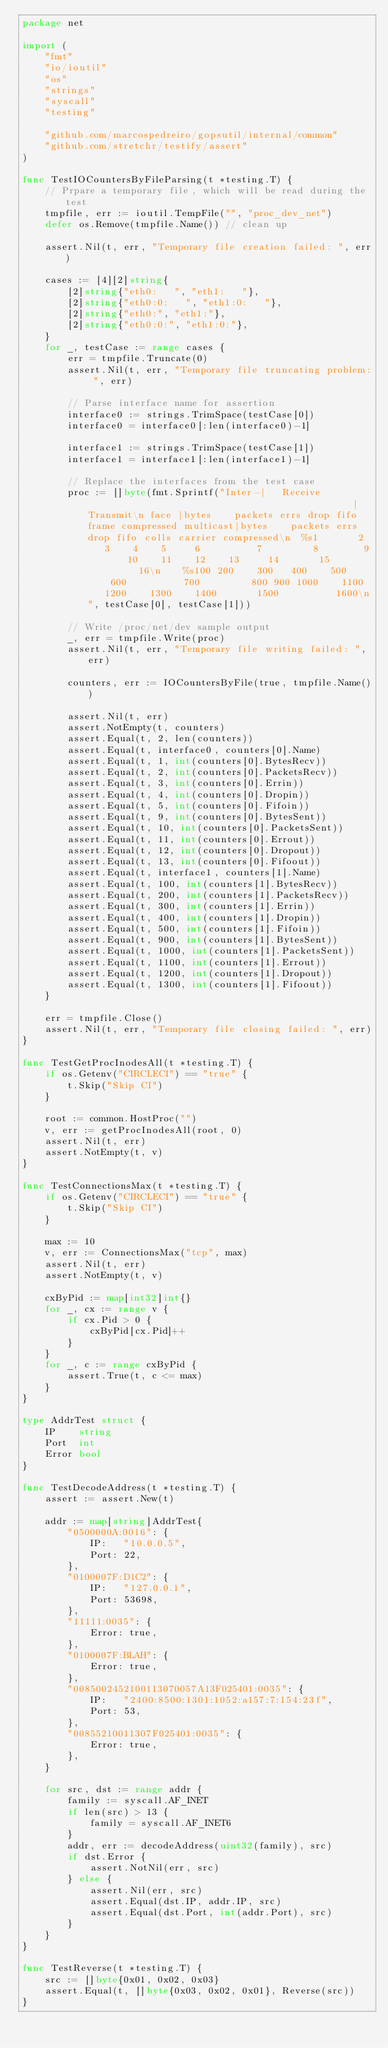Convert code to text. <code><loc_0><loc_0><loc_500><loc_500><_Go_>package net

import (
	"fmt"
	"io/ioutil"
	"os"
	"strings"
	"syscall"
	"testing"

	"github.com/marcospedreiro/gopsutil/internal/common"
	"github.com/stretchr/testify/assert"
)

func TestIOCountersByFileParsing(t *testing.T) {
	// Prpare a temporary file, which will be read during the test
	tmpfile, err := ioutil.TempFile("", "proc_dev_net")
	defer os.Remove(tmpfile.Name()) // clean up

	assert.Nil(t, err, "Temporary file creation failed: ", err)

	cases := [4][2]string{
		[2]string{"eth0:   ", "eth1:   "},
		[2]string{"eth0:0:   ", "eth1:0:   "},
		[2]string{"eth0:", "eth1:"},
		[2]string{"eth0:0:", "eth1:0:"},
	}
	for _, testCase := range cases {
		err = tmpfile.Truncate(0)
		assert.Nil(t, err, "Temporary file truncating problem: ", err)

		// Parse interface name for assertion
		interface0 := strings.TrimSpace(testCase[0])
		interface0 = interface0[:len(interface0)-1]

		interface1 := strings.TrimSpace(testCase[1])
		interface1 = interface1[:len(interface1)-1]

		// Replace the interfaces from the test case
		proc := []byte(fmt.Sprintf("Inter-|   Receive                                                |  Transmit\n face |bytes    packets errs drop fifo frame compressed multicast|bytes    packets errs drop fifo colls carrier compressed\n  %s1       2    3    4    5     6          7         8        9       10    11    12    13     14       15          16\n    %s100 200    300   400    500     600          700         800 900 1000    1100    1200    1300    1400       1500          1600\n", testCase[0], testCase[1]))

		// Write /proc/net/dev sample output
		_, err = tmpfile.Write(proc)
		assert.Nil(t, err, "Temporary file writing failed: ", err)

		counters, err := IOCountersByFile(true, tmpfile.Name())

		assert.Nil(t, err)
		assert.NotEmpty(t, counters)
		assert.Equal(t, 2, len(counters))
		assert.Equal(t, interface0, counters[0].Name)
		assert.Equal(t, 1, int(counters[0].BytesRecv))
		assert.Equal(t, 2, int(counters[0].PacketsRecv))
		assert.Equal(t, 3, int(counters[0].Errin))
		assert.Equal(t, 4, int(counters[0].Dropin))
		assert.Equal(t, 5, int(counters[0].Fifoin))
		assert.Equal(t, 9, int(counters[0].BytesSent))
		assert.Equal(t, 10, int(counters[0].PacketsSent))
		assert.Equal(t, 11, int(counters[0].Errout))
		assert.Equal(t, 12, int(counters[0].Dropout))
		assert.Equal(t, 13, int(counters[0].Fifoout))
		assert.Equal(t, interface1, counters[1].Name)
		assert.Equal(t, 100, int(counters[1].BytesRecv))
		assert.Equal(t, 200, int(counters[1].PacketsRecv))
		assert.Equal(t, 300, int(counters[1].Errin))
		assert.Equal(t, 400, int(counters[1].Dropin))
		assert.Equal(t, 500, int(counters[1].Fifoin))
		assert.Equal(t, 900, int(counters[1].BytesSent))
		assert.Equal(t, 1000, int(counters[1].PacketsSent))
		assert.Equal(t, 1100, int(counters[1].Errout))
		assert.Equal(t, 1200, int(counters[1].Dropout))
		assert.Equal(t, 1300, int(counters[1].Fifoout))
	}

	err = tmpfile.Close()
	assert.Nil(t, err, "Temporary file closing failed: ", err)
}

func TestGetProcInodesAll(t *testing.T) {
	if os.Getenv("CIRCLECI") == "true" {
		t.Skip("Skip CI")
	}

	root := common.HostProc("")
	v, err := getProcInodesAll(root, 0)
	assert.Nil(t, err)
	assert.NotEmpty(t, v)
}

func TestConnectionsMax(t *testing.T) {
	if os.Getenv("CIRCLECI") == "true" {
		t.Skip("Skip CI")
	}

	max := 10
	v, err := ConnectionsMax("tcp", max)
	assert.Nil(t, err)
	assert.NotEmpty(t, v)

	cxByPid := map[int32]int{}
	for _, cx := range v {
		if cx.Pid > 0 {
			cxByPid[cx.Pid]++
		}
	}
	for _, c := range cxByPid {
		assert.True(t, c <= max)
	}
}

type AddrTest struct {
	IP    string
	Port  int
	Error bool
}

func TestDecodeAddress(t *testing.T) {
	assert := assert.New(t)

	addr := map[string]AddrTest{
		"0500000A:0016": {
			IP:   "10.0.0.5",
			Port: 22,
		},
		"0100007F:D1C2": {
			IP:   "127.0.0.1",
			Port: 53698,
		},
		"11111:0035": {
			Error: true,
		},
		"0100007F:BLAH": {
			Error: true,
		},
		"0085002452100113070057A13F025401:0035": {
			IP:   "2400:8500:1301:1052:a157:7:154:23f",
			Port: 53,
		},
		"00855210011307F025401:0035": {
			Error: true,
		},
	}

	for src, dst := range addr {
		family := syscall.AF_INET
		if len(src) > 13 {
			family = syscall.AF_INET6
		}
		addr, err := decodeAddress(uint32(family), src)
		if dst.Error {
			assert.NotNil(err, src)
		} else {
			assert.Nil(err, src)
			assert.Equal(dst.IP, addr.IP, src)
			assert.Equal(dst.Port, int(addr.Port), src)
		}
	}
}

func TestReverse(t *testing.T) {
	src := []byte{0x01, 0x02, 0x03}
	assert.Equal(t, []byte{0x03, 0x02, 0x01}, Reverse(src))
}
</code> 